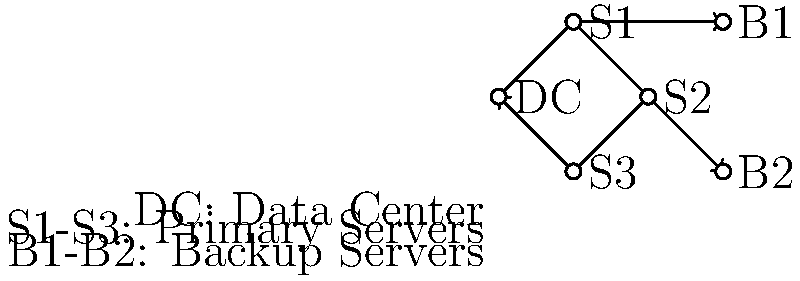In the given network topology diagram for disaster recovery planning, which server would be the most critical to protect to ensure minimal data loss in case of a disaster affecting the main data center (DC)? To answer this question, we need to analyze the network topology and understand the role of each component in disaster recovery:

1. The diagram shows a main data center (DC) connected to three primary servers (S1, S2, S3) in a ring topology.
2. Two backup servers (B1, B2) are connected to S1 and S2 respectively.
3. In disaster recovery, the goal is to minimize data loss and ensure business continuity.
4. The most critical server would be the one that:
   a) Has the most connections to other servers
   b) Is connected to a backup server
   c) Is positioned to receive data from multiple sources

5. Analyzing the servers:
   - S1 is connected to DC, S2, S3, and B1
   - S2 is connected to DC, S1, S3, and B2
   - S3 is connected to DC, S1, and S2, but not to any backup server

6. S1 and S2 have equal connections (4 each) and are both connected to backup servers.
7. However, S1 is positioned between DC and B1, making it more likely to have the most up-to-date data from the data center and be able to quickly replicate to the backup server.

Therefore, S1 would be the most critical server to protect to ensure minimal data loss in case of a disaster affecting the main data center.
Answer: S1 